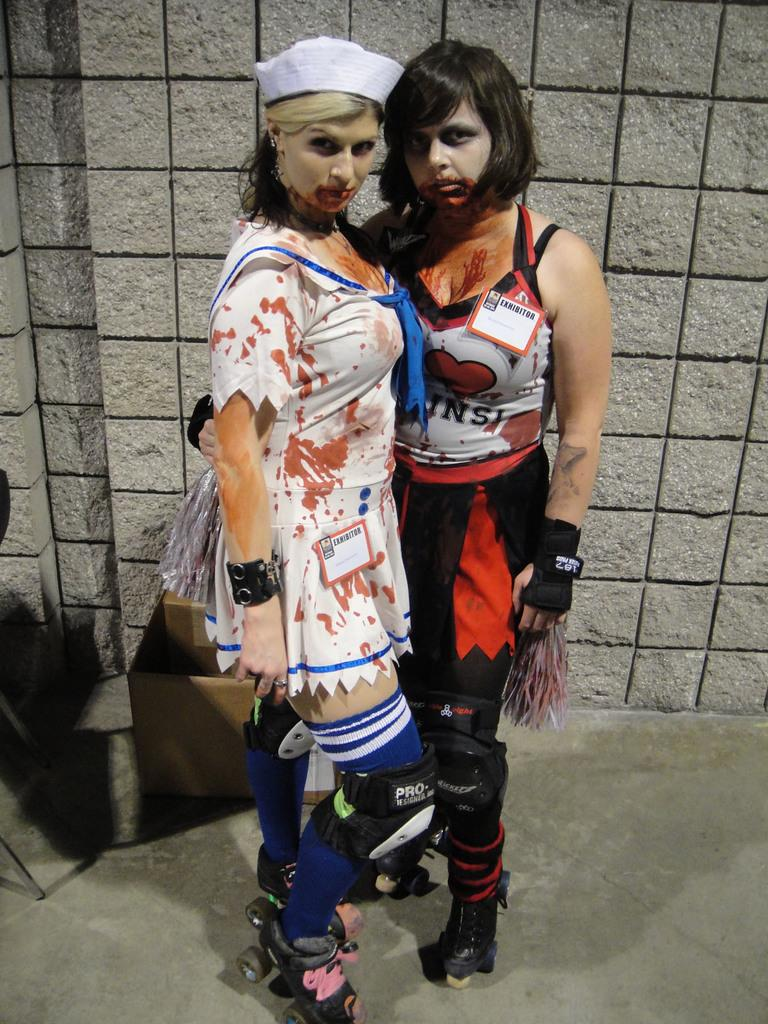How many people are in the image? There are two persons in the image. What are the persons wearing? The persons are wearing fancy dresses. What object can be seen in the image besides the people? There is a cardboard box in the image. What is visible in the background of the image? There is a wall in the background of the image. What type of cracker is being used as a prop in the image? There is no cracker present in the image. Can you describe the truck that is parked behind the wall in the image? There is no truck visible in the image; only a wall is present in the background. 